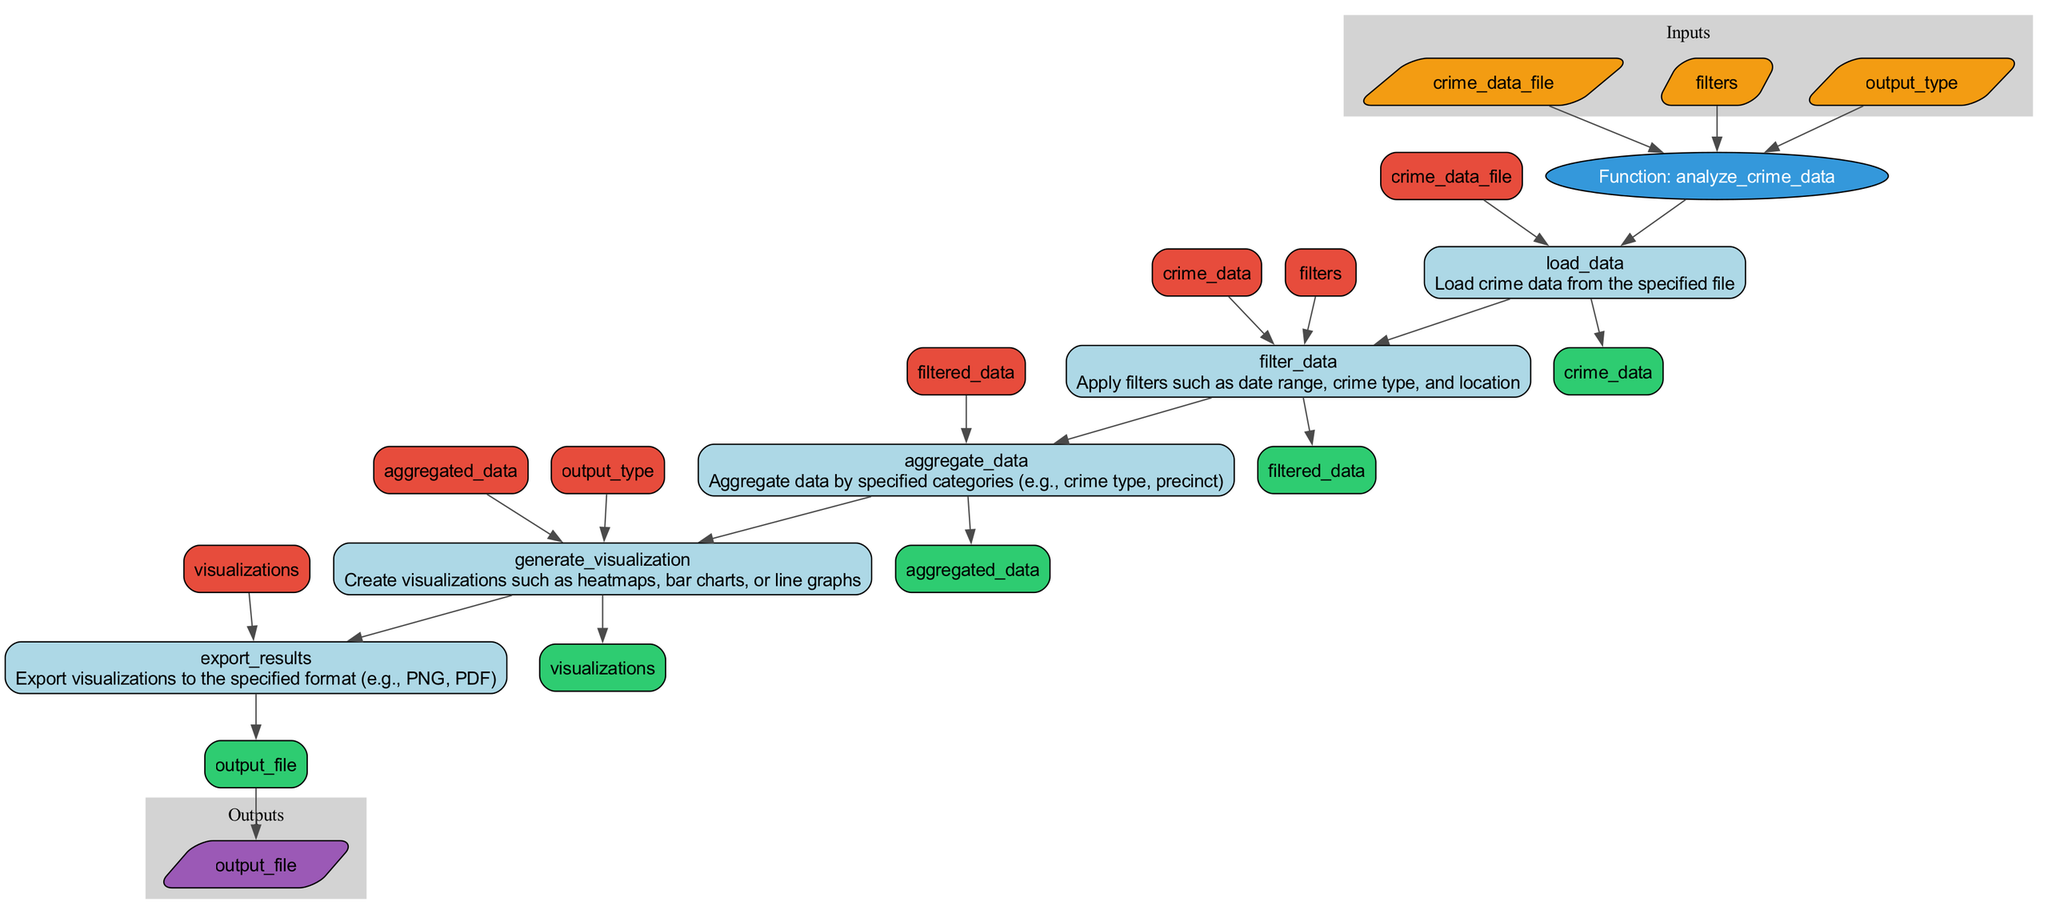What is the name of the function in this diagram? The function name is labeled at the top of the diagram inside an oval shape. The label clearly states "Function: analyze_crime_data".
Answer: analyze_crime_data How many inputs does the function have? The diagram lists three inputs connected to the function node. Each input is represented in a parallelogram labeled in the 'Inputs' section.
Answer: 3 What is the output of the last step in the flowchart? The last step is named "export_results", which indicates that it outputs an "output_file". This is shown in the 'Outputs' section connected to the last node's output.
Answer: output_file What is the description of the step "filter_data"? To find the description, look for the "filter_data" step in the flowchart, which states: "Apply filters such as date range, crime type, and location". This description is included in the rectangle of that step.
Answer: Apply filters such as date range, crime type, and location Which step generates visualizations? In the flowchart, the step "generate_visualization" is specifically responsible for creating visualizations. It is connected to the aggregated data and includes "Create visualizations such as heatmaps, bar charts, or line graphs" in its description.
Answer: generate_visualization What inputs does the "aggregate_data" step take? The "aggregate_data" step takes "filtered_data" as input. This input is directly connected to the "filter_data" step, as shown in the diagram.
Answer: filtered_data What are the types of visualizations mentioned in the "generate_visualization" step? The step description indicates the types of visualizations that can be generated: "heatmaps, bar charts, or line graphs". These are explicitly stated in the description of the visualization step.
Answer: heatmaps, bar charts, or line graphs What is the connection between the "load_data" step and the "filter_data" step? The "load_data" step outputs "crime_data", which serves as the input for the "filter_data" step. This flow indicates that after loading data, it is filtered in the next step.
Answer: crime_data Which step would you reach if you wanted to see the exported results? The flowchart connects the last step "export_results" directly to the output of the function. To reach this step, you follow the flow from the previous steps leading to the final output.
Answer: export_results 